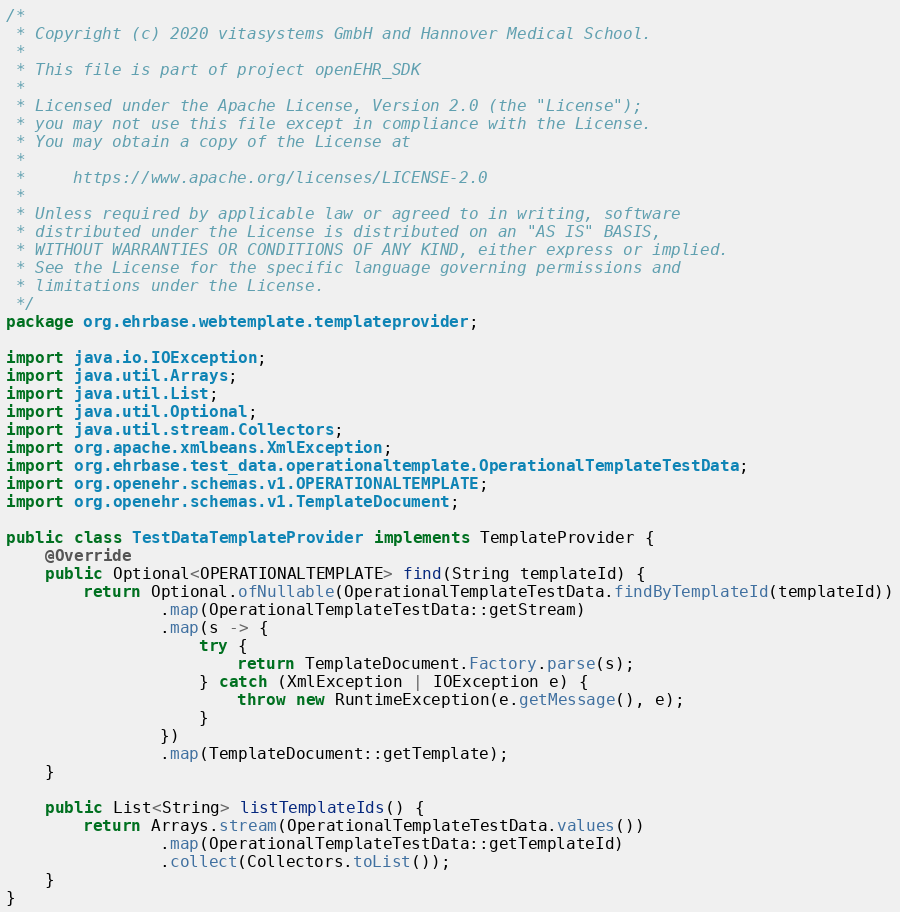Convert code to text. <code><loc_0><loc_0><loc_500><loc_500><_Java_>/*
 * Copyright (c) 2020 vitasystems GmbH and Hannover Medical School.
 *
 * This file is part of project openEHR_SDK
 *
 * Licensed under the Apache License, Version 2.0 (the "License");
 * you may not use this file except in compliance with the License.
 * You may obtain a copy of the License at
 *
 *     https://www.apache.org/licenses/LICENSE-2.0
 *
 * Unless required by applicable law or agreed to in writing, software
 * distributed under the License is distributed on an "AS IS" BASIS,
 * WITHOUT WARRANTIES OR CONDITIONS OF ANY KIND, either express or implied.
 * See the License for the specific language governing permissions and
 * limitations under the License.
 */
package org.ehrbase.webtemplate.templateprovider;

import java.io.IOException;
import java.util.Arrays;
import java.util.List;
import java.util.Optional;
import java.util.stream.Collectors;
import org.apache.xmlbeans.XmlException;
import org.ehrbase.test_data.operationaltemplate.OperationalTemplateTestData;
import org.openehr.schemas.v1.OPERATIONALTEMPLATE;
import org.openehr.schemas.v1.TemplateDocument;

public class TestDataTemplateProvider implements TemplateProvider {
    @Override
    public Optional<OPERATIONALTEMPLATE> find(String templateId) {
        return Optional.ofNullable(OperationalTemplateTestData.findByTemplateId(templateId))
                .map(OperationalTemplateTestData::getStream)
                .map(s -> {
                    try {
                        return TemplateDocument.Factory.parse(s);
                    } catch (XmlException | IOException e) {
                        throw new RuntimeException(e.getMessage(), e);
                    }
                })
                .map(TemplateDocument::getTemplate);
    }

    public List<String> listTemplateIds() {
        return Arrays.stream(OperationalTemplateTestData.values())
                .map(OperationalTemplateTestData::getTemplateId)
                .collect(Collectors.toList());
    }
}
</code> 